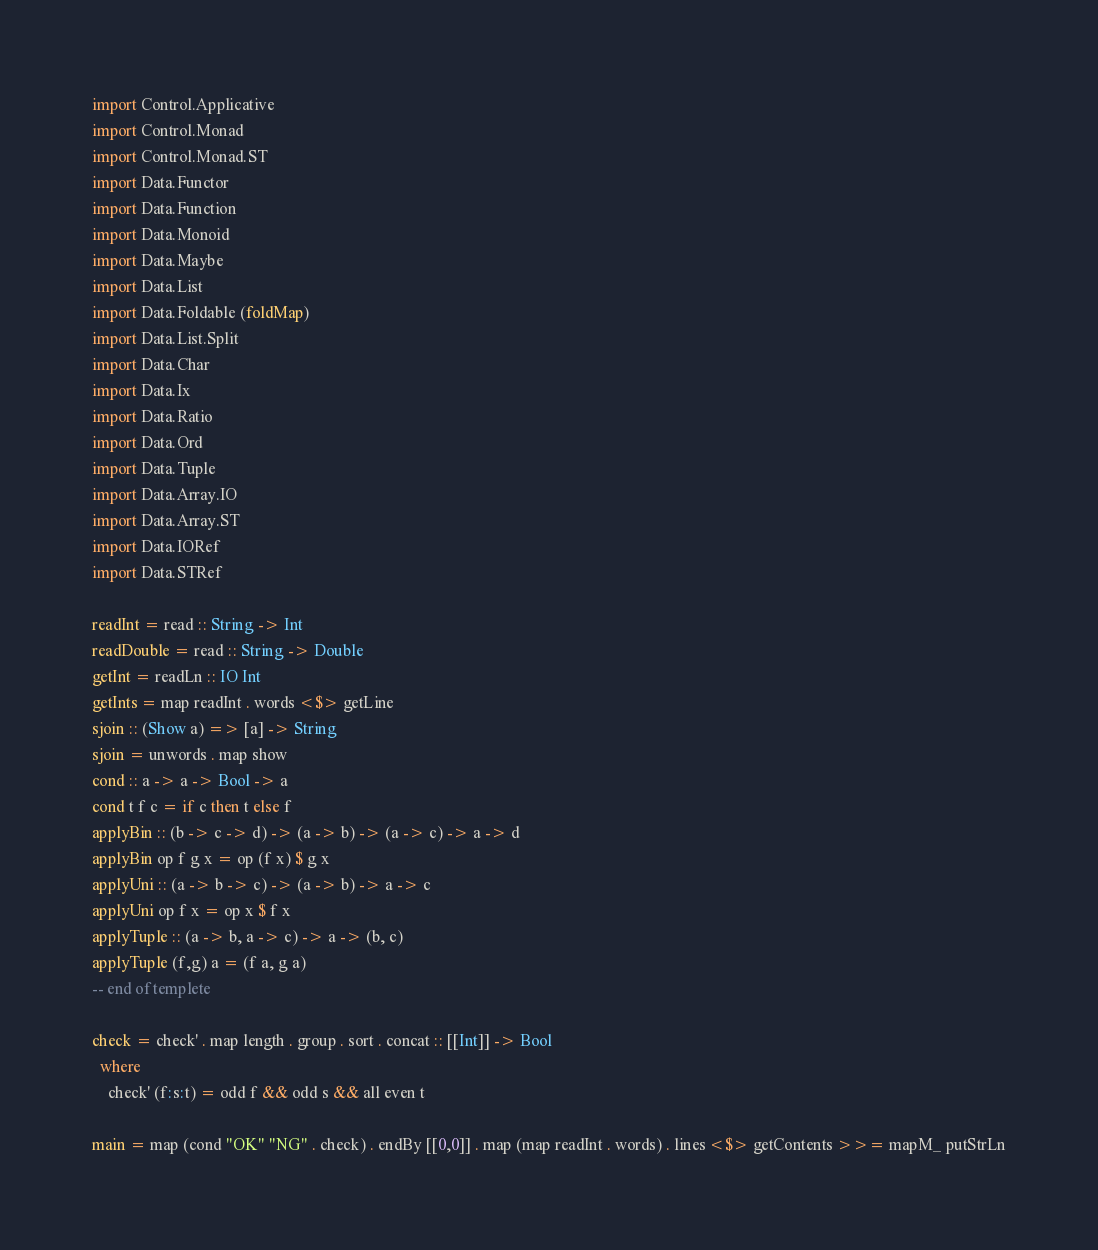Convert code to text. <code><loc_0><loc_0><loc_500><loc_500><_Haskell_>import Control.Applicative
import Control.Monad
import Control.Monad.ST
import Data.Functor
import Data.Function
import Data.Monoid
import Data.Maybe
import Data.List
import Data.Foldable (foldMap)
import Data.List.Split
import Data.Char
import Data.Ix
import Data.Ratio
import Data.Ord
import Data.Tuple
import Data.Array.IO
import Data.Array.ST
import Data.IORef
import Data.STRef
 
readInt = read :: String -> Int
readDouble = read :: String -> Double
getInt = readLn :: IO Int
getInts = map readInt . words <$> getLine
sjoin :: (Show a) => [a] -> String
sjoin = unwords . map show
cond :: a -> a -> Bool -> a
cond t f c = if c then t else f
applyBin :: (b -> c -> d) -> (a -> b) -> (a -> c) -> a -> d
applyBin op f g x = op (f x) $ g x
applyUni :: (a -> b -> c) -> (a -> b) -> a -> c
applyUni op f x = op x $ f x
applyTuple :: (a -> b, a -> c) -> a -> (b, c)
applyTuple (f,g) a = (f a, g a)
-- end of templete

check = check' . map length . group . sort . concat :: [[Int]] -> Bool
  where
    check' (f:s:t) = odd f && odd s && all even t

main = map (cond "OK" "NG" . check) . endBy [[0,0]] . map (map readInt . words) . lines <$> getContents >>= mapM_ putStrLn</code> 